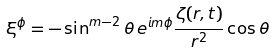Convert formula to latex. <formula><loc_0><loc_0><loc_500><loc_500>\xi ^ { \phi } = - \sin ^ { m - 2 } \theta \, e ^ { i m \phi } \frac { \zeta ( r , t ) } { r ^ { 2 } } \cos \theta</formula> 